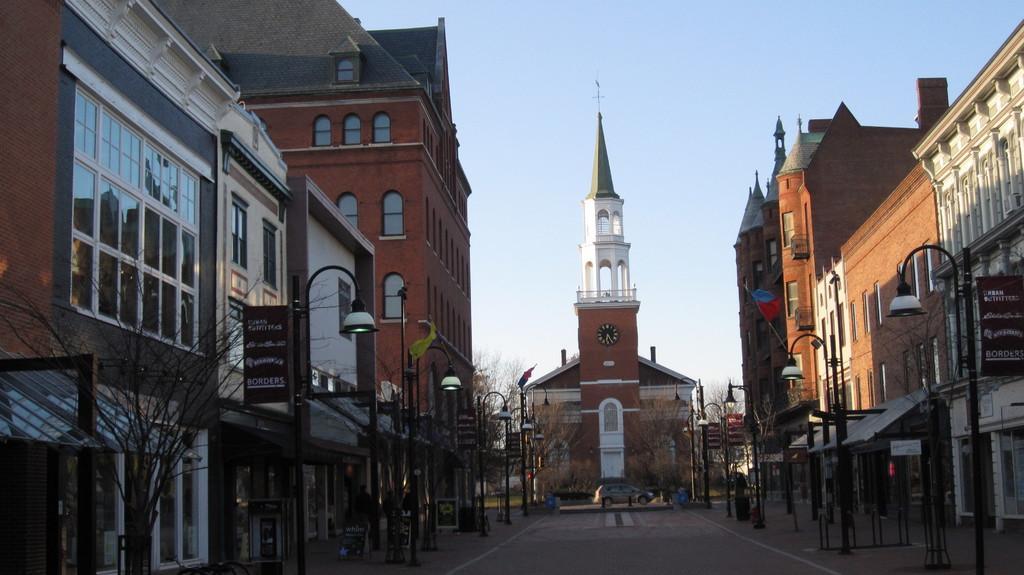Please provide a concise description of this image. This image consists of building. In the middle, there is a road. In the front, we can see a clock tower. At the top, there is a sky. On the left, there is a tree. 